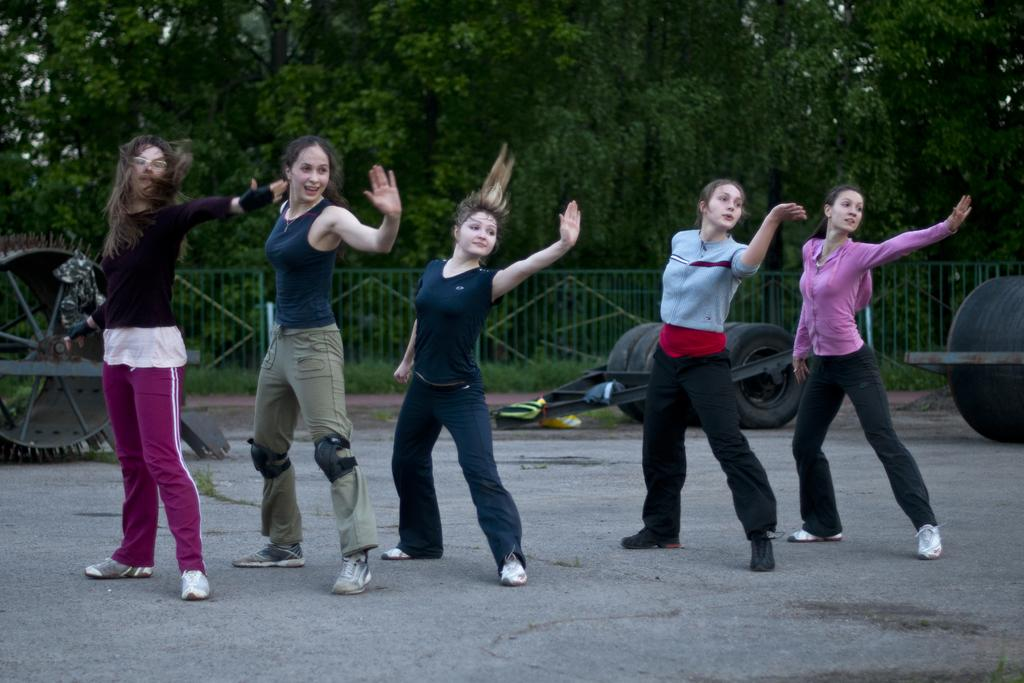Who or what can be seen in the image? There are people in the image. What is the surface that the people are standing on? The ground is visible in the image. What type of equipment is present in the image? There are rollers in the image. What type of vegetation is present in the image? There is grass, plants, and trees in the image. What type of barrier is present in the image? There is a fence in the image. Which direction is the tooth facing in the image? There is no tooth present in the image. What nation is depicted in the image? The image does not depict a specific nation; it features people, rollers, and natural elements. 